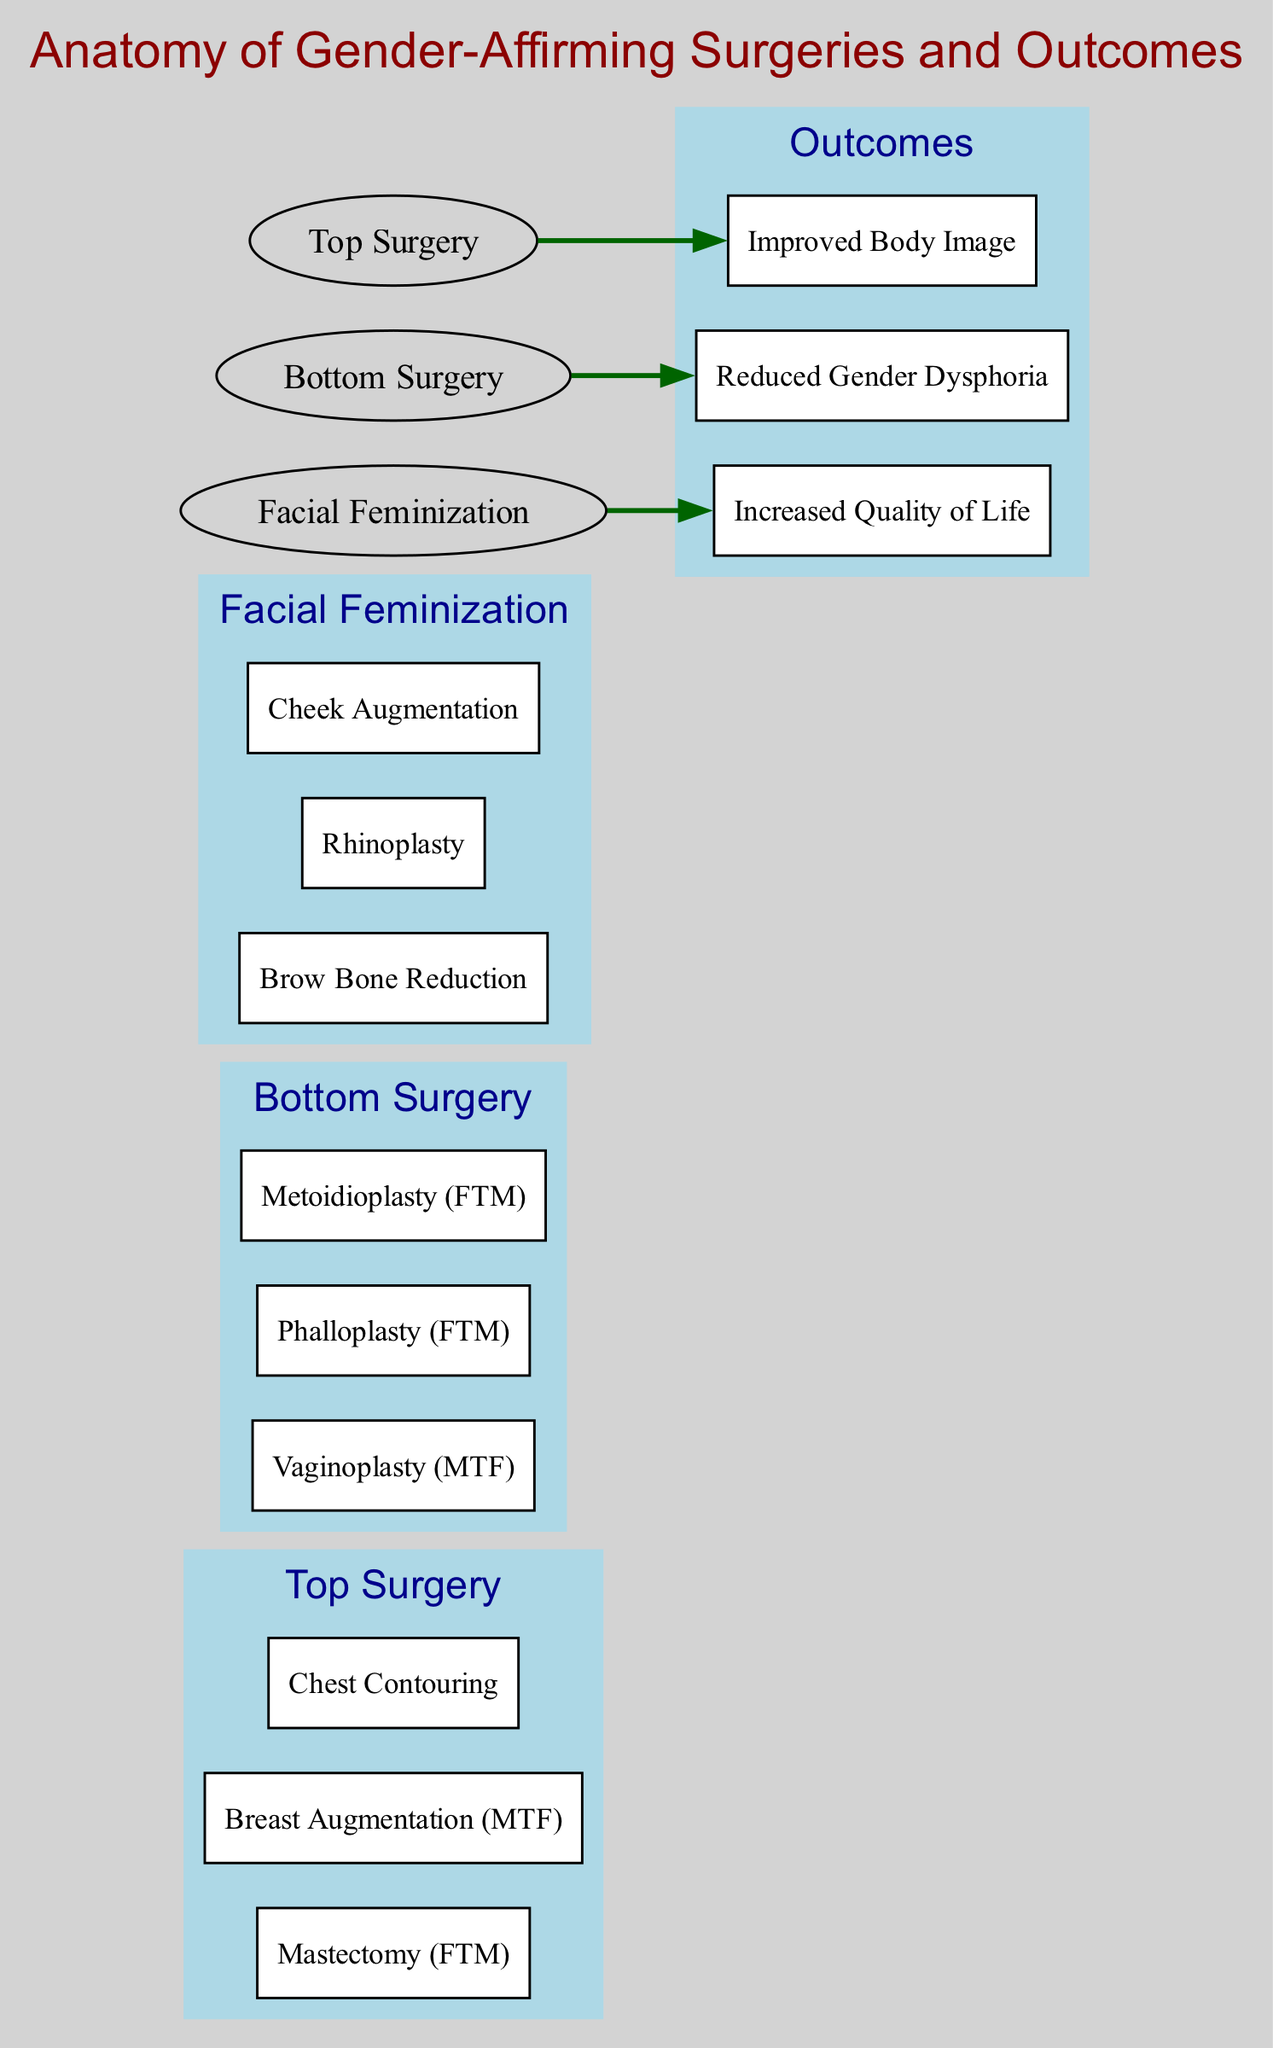What are the three elements listed under Top Surgery? The elements under Top Surgery are identified in the diagram; they include Mastectomy (FTM), Breast Augmentation (MTF), and Chest Contouring.
Answer: Mastectomy (FTM), Breast Augmentation (MTF), Chest Contouring How many elements are present under Bottom Surgery? To find the number of elements under Bottom Surgery, we look at the section labeled "Bottom Surgery" in the diagram. There are three elements listed: Vaginoplasty (MTF), Phalloplasty (FTM), and Metoidioplasty (FTM).
Answer: 3 Which outcome is associated with Facial Feminization? The connection from Facial Feminization in the diagram shows that it is linked to Increased Quality of Life.
Answer: Increased Quality of Life What are the connections listed in the diagram? The connections in the diagram detail the relationships between surgery types and outcomes: Top Surgery connects to Improved Body Image, Bottom Surgery connects to Reduced Gender Dysphoria, and Facial Feminization connects to Increased Quality of Life.
Answer: Top Surgery -> Improved Body Image, Bottom Surgery -> Reduced Gender Dysphoria, Facial Feminization -> Increased Quality of Life Which section has three specific procedures: Brow Bone Reduction, Rhinoplasty, and Cheek Augmentation? By identifying the section in the diagram labeled "Facial Feminization," we see that it includes the procedures mentioned.
Answer: Facial Feminization How do Top Surgery and Bottom Surgery contribute to outcomes? In the diagram, Top Surgery is shown to lead to Improved Body Image, while Bottom Surgery is related to Reduced Gender Dysphoria. This indicates how they influence specific outcomes.
Answer: Top Surgery -> Improved Body Image, Bottom Surgery -> Reduced Gender Dysphoria What is the total number of sections depicted in the diagram? The total number of sections can be counted by identifying the headers in the diagram: Top Surgery, Bottom Surgery, Facial Feminization, and Outcomes. This totals four distinct sections.
Answer: 4 